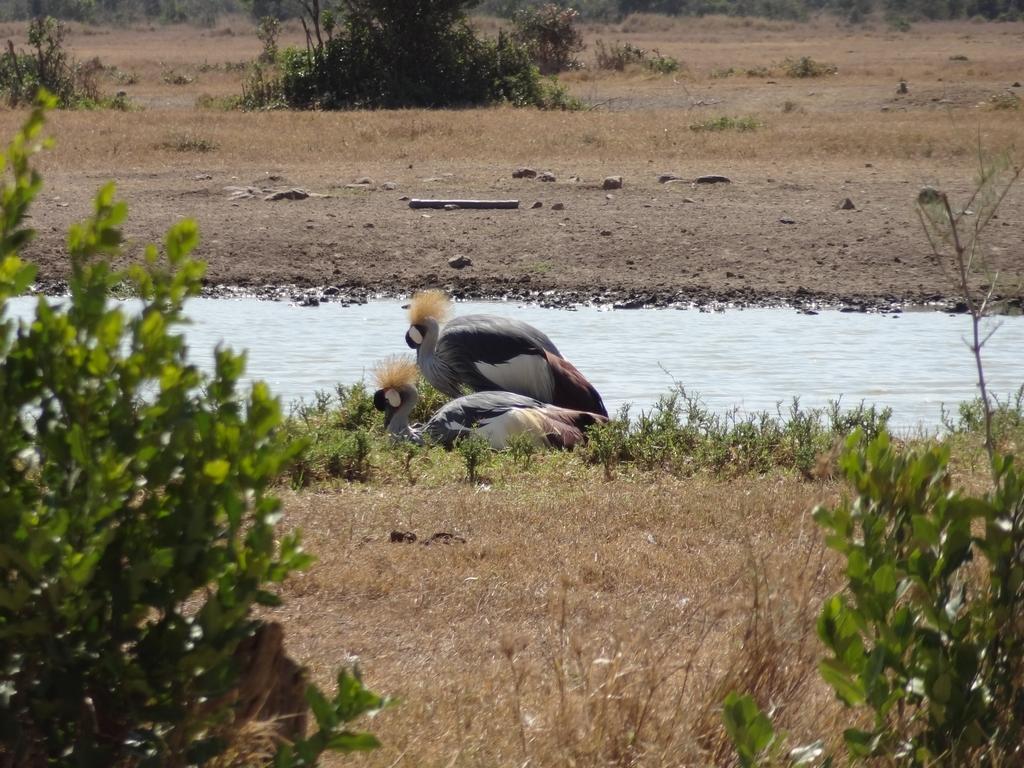Can you describe this image briefly? This picture is taken from the outside of the city. In this image, in the middle, we can see two birds which are on the grass. In the right corner, we can see some plants. In the left corner, we can see some plants. In the background, we can see some trees. at the bottom, we can see a land with some stones and water in a lake. 